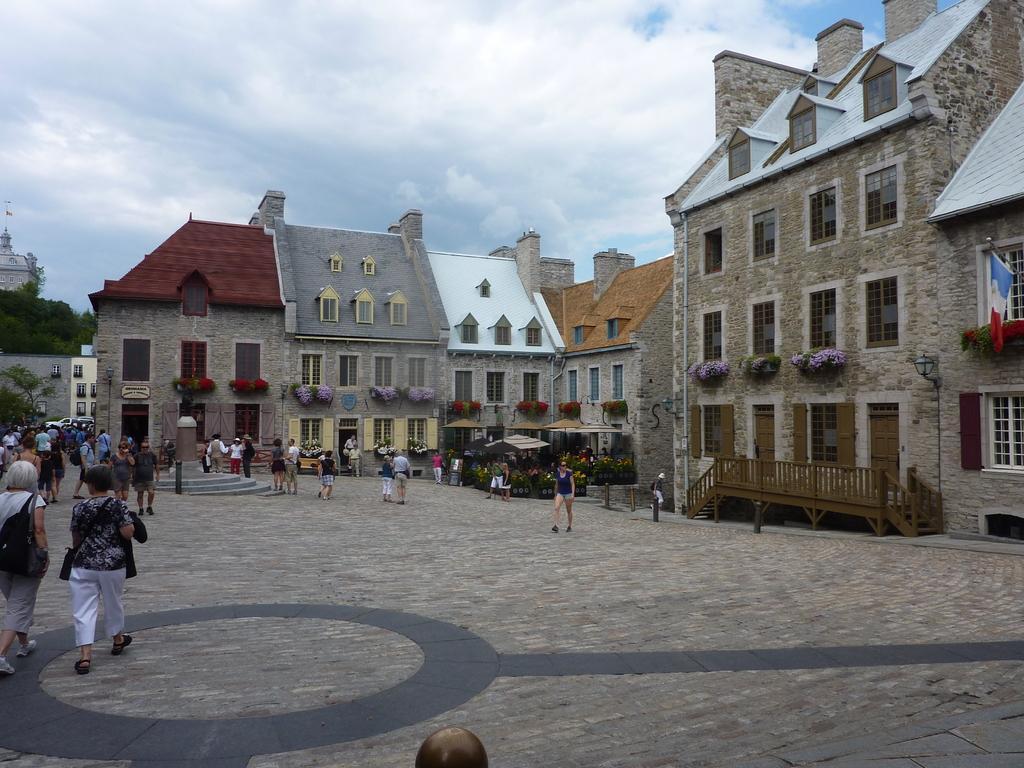Can you describe this image briefly? As we can see in the image there is a clear sky and there are lot of buildings all around which are made of bricks and at the bottom there is a road on which people are walking. On behind of buildings there are lot of trees. 